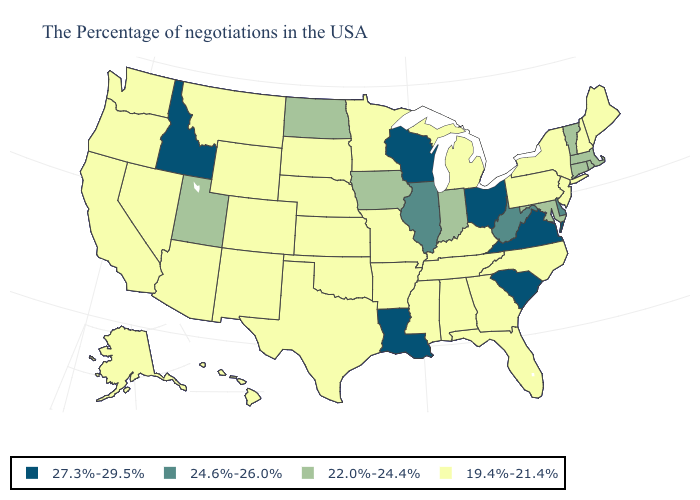What is the value of Delaware?
Quick response, please. 24.6%-26.0%. What is the value of Tennessee?
Answer briefly. 19.4%-21.4%. Does New Jersey have the highest value in the Northeast?
Write a very short answer. No. Does the first symbol in the legend represent the smallest category?
Keep it brief. No. What is the highest value in the West ?
Give a very brief answer. 27.3%-29.5%. Name the states that have a value in the range 24.6%-26.0%?
Write a very short answer. Delaware, West Virginia, Illinois. Name the states that have a value in the range 24.6%-26.0%?
Be succinct. Delaware, West Virginia, Illinois. Is the legend a continuous bar?
Give a very brief answer. No. Does Arizona have the highest value in the West?
Keep it brief. No. What is the value of South Dakota?
Answer briefly. 19.4%-21.4%. Is the legend a continuous bar?
Be succinct. No. Does the map have missing data?
Be succinct. No. What is the value of Vermont?
Keep it brief. 22.0%-24.4%. What is the value of New York?
Concise answer only. 19.4%-21.4%. Among the states that border Nebraska , does South Dakota have the lowest value?
Quick response, please. Yes. 